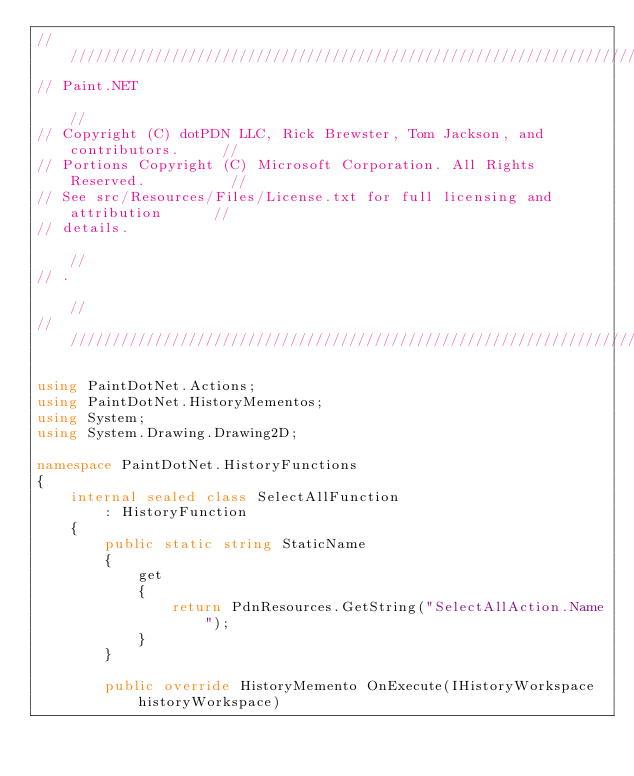Convert code to text. <code><loc_0><loc_0><loc_500><loc_500><_C#_>/////////////////////////////////////////////////////////////////////////////////
// Paint.NET                                                                   //
// Copyright (C) dotPDN LLC, Rick Brewster, Tom Jackson, and contributors.     //
// Portions Copyright (C) Microsoft Corporation. All Rights Reserved.          //
// See src/Resources/Files/License.txt for full licensing and attribution      //
// details.                                                                    //
// .                                                                           //
/////////////////////////////////////////////////////////////////////////////////

using PaintDotNet.Actions;
using PaintDotNet.HistoryMementos;
using System;
using System.Drawing.Drawing2D;

namespace PaintDotNet.HistoryFunctions
{
    internal sealed class SelectAllFunction
        : HistoryFunction
    {
        public static string StaticName
        {
            get
            {
                return PdnResources.GetString("SelectAllAction.Name");
            }
        }

        public override HistoryMemento OnExecute(IHistoryWorkspace historyWorkspace)</code> 